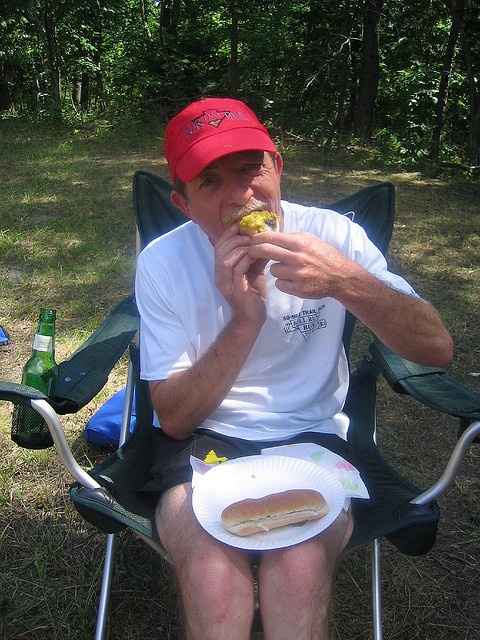Describe the objects in this image and their specific colors. I can see people in black, brown, gray, darkgray, and lavender tones, chair in black, darkblue, gray, and blue tones, hot dog in black, darkgray, and gray tones, sandwich in black, darkgray, and gray tones, and bottle in black, darkgreen, green, and teal tones in this image. 